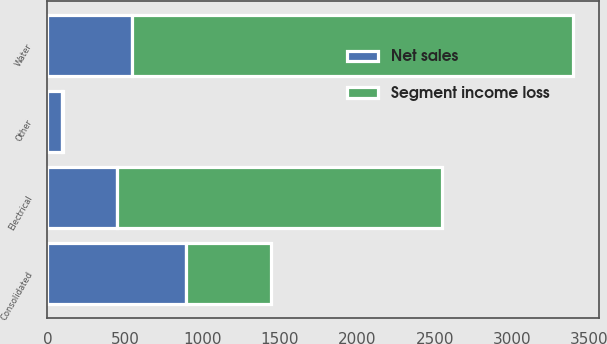Convert chart to OTSL. <chart><loc_0><loc_0><loc_500><loc_500><stacked_bar_chart><ecel><fcel>Water<fcel>Electrical<fcel>Other<fcel>Consolidated<nl><fcel>Segment income loss<fcel>2844.4<fcel>2097.9<fcel>5.8<fcel>546<nl><fcel>Net sales<fcel>546<fcel>447<fcel>95.8<fcel>897.2<nl></chart> 